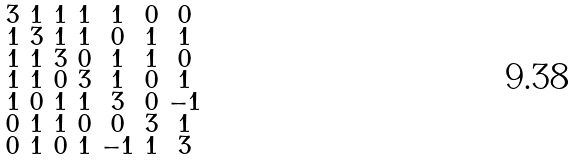Convert formula to latex. <formula><loc_0><loc_0><loc_500><loc_500>\begin{smallmatrix} 3 & 1 & 1 & 1 & 1 & 0 & 0 \\ 1 & 3 & 1 & 1 & 0 & 1 & 1 \\ 1 & 1 & 3 & 0 & 1 & 1 & 0 \\ 1 & 1 & 0 & 3 & 1 & 0 & 1 \\ 1 & 0 & 1 & 1 & 3 & 0 & - 1 \\ 0 & 1 & 1 & 0 & 0 & 3 & 1 \\ 0 & 1 & 0 & 1 & - 1 & 1 & 3 \end{smallmatrix}</formula> 